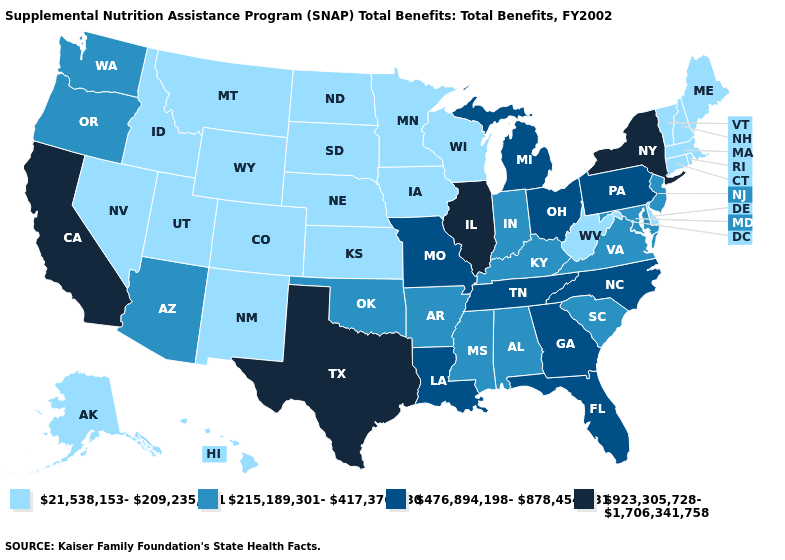What is the highest value in the MidWest ?
Keep it brief. 923,305,728-1,706,341,758. What is the value of South Carolina?
Keep it brief. 215,189,301-417,376,930. Does New Jersey have the lowest value in the Northeast?
Concise answer only. No. Among the states that border Indiana , which have the highest value?
Short answer required. Illinois. What is the lowest value in states that border Mississippi?
Answer briefly. 215,189,301-417,376,930. Does Missouri have the highest value in the USA?
Short answer required. No. What is the value of Wisconsin?
Be succinct. 21,538,153-209,235,751. Does Maryland have the highest value in the South?
Be succinct. No. Does Connecticut have a lower value than Virginia?
Give a very brief answer. Yes. Which states have the lowest value in the Northeast?
Concise answer only. Connecticut, Maine, Massachusetts, New Hampshire, Rhode Island, Vermont. What is the value of Missouri?
Concise answer only. 476,894,198-878,454,831. Name the states that have a value in the range 215,189,301-417,376,930?
Answer briefly. Alabama, Arizona, Arkansas, Indiana, Kentucky, Maryland, Mississippi, New Jersey, Oklahoma, Oregon, South Carolina, Virginia, Washington. Does Pennsylvania have the lowest value in the Northeast?
Short answer required. No. Name the states that have a value in the range 476,894,198-878,454,831?
Answer briefly. Florida, Georgia, Louisiana, Michigan, Missouri, North Carolina, Ohio, Pennsylvania, Tennessee. Does Kentucky have the same value as Mississippi?
Be succinct. Yes. 